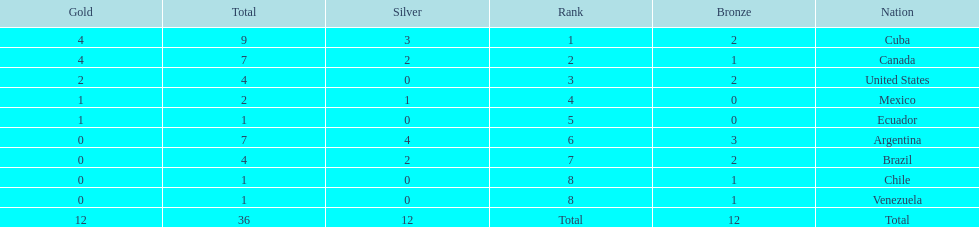Which ranking is mexico? 4. Parse the full table. {'header': ['Gold', 'Total', 'Silver', 'Rank', 'Bronze', 'Nation'], 'rows': [['4', '9', '3', '1', '2', 'Cuba'], ['4', '7', '2', '2', '1', 'Canada'], ['2', '4', '0', '3', '2', 'United States'], ['1', '2', '1', '4', '0', 'Mexico'], ['1', '1', '0', '5', '0', 'Ecuador'], ['0', '7', '4', '6', '3', 'Argentina'], ['0', '4', '2', '7', '2', 'Brazil'], ['0', '1', '0', '8', '1', 'Chile'], ['0', '1', '0', '8', '1', 'Venezuela'], ['12', '36', '12', 'Total', '12', 'Total']]} 